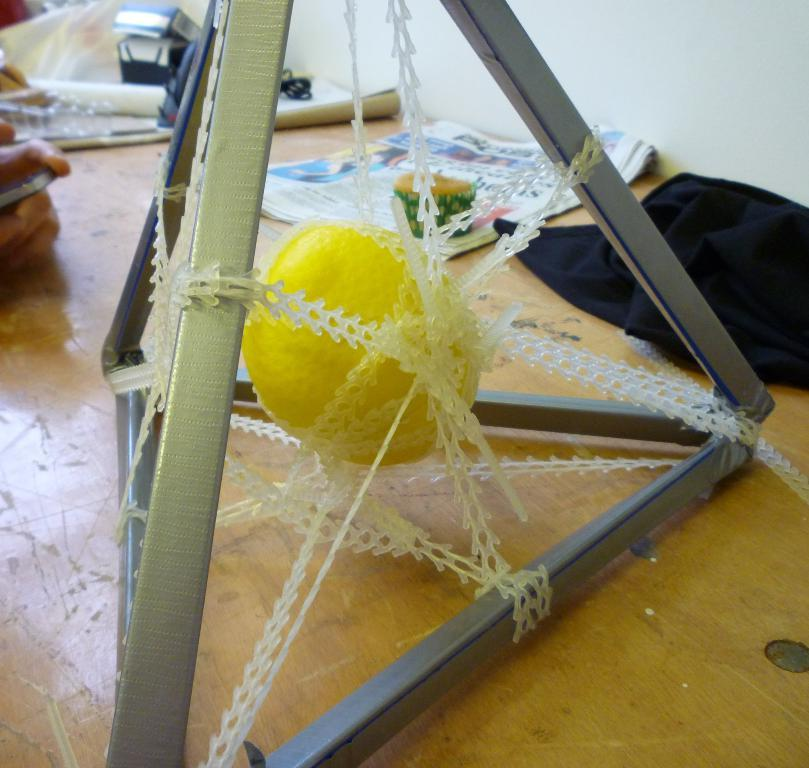What is the color of the wall in the image? The wall in the image is white. What piece of furniture is present in the image? There is a table in the image. What is on the table in the image? There is a metal stand and a yellow color object on the table. What type of material is covering the table in the image? There is a cloth on the table. Whose hand is visible in the image? A human hand is visible in the image. What time is displayed on the clock in the image? There is no clock present in the image. How does the net prevent the object from falling in the image? There is no net present in the image, so it cannot prevent any object from falling. 